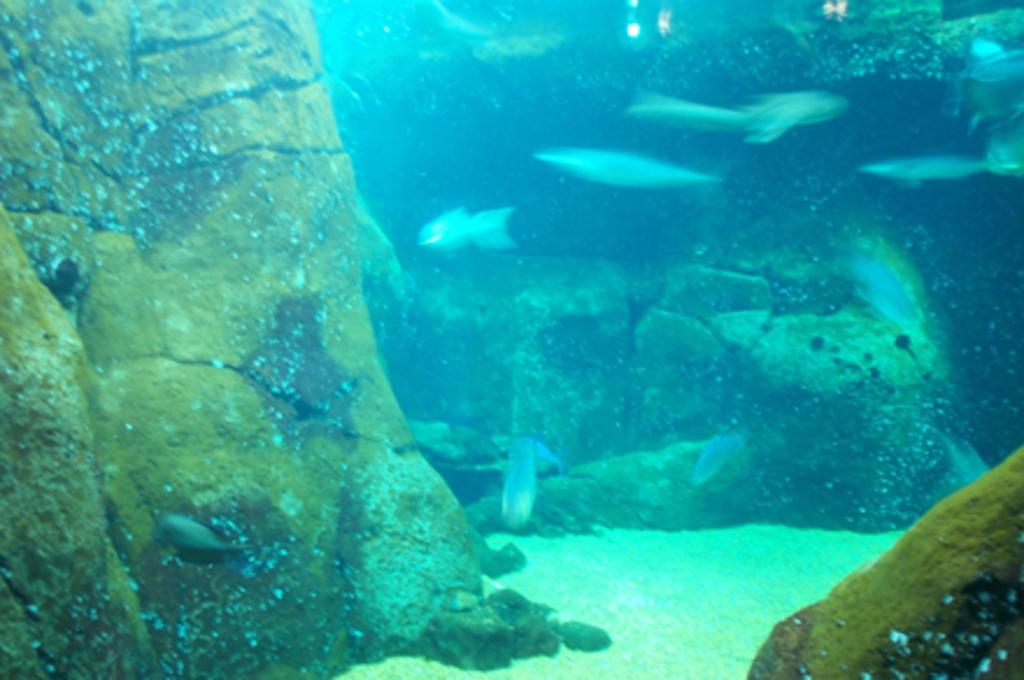What type of animals can be seen under the water in the image? There are fishes under the water in the image. What type of plant life is present under the water? There is algae under the water. What type of sticks can be seen in the image? There are no sticks visible in the image. 